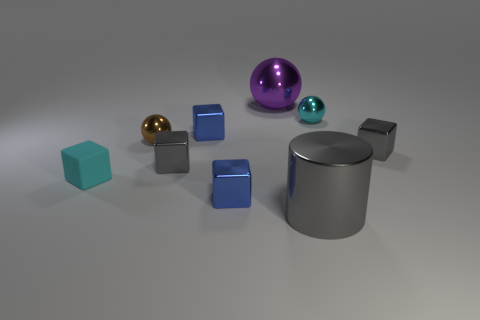What is the color of the small metallic thing that is behind the brown metallic ball and to the right of the purple metallic object?
Make the answer very short. Cyan. Is the number of big balls that are right of the purple metallic object less than the number of cyan objects behind the cyan matte block?
Your answer should be compact. Yes. What number of large gray objects are the same shape as the cyan matte object?
Give a very brief answer. 0. What size is the cyan thing that is made of the same material as the big gray object?
Offer a terse response. Small. There is a small shiny ball left of the big gray cylinder that is in front of the large purple ball; what is its color?
Give a very brief answer. Brown. Is the shape of the cyan metallic object the same as the gray thing in front of the cyan cube?
Keep it short and to the point. No. What number of blue things have the same size as the gray metal cylinder?
Make the answer very short. 0. There is a big metal thing that is in front of the big metal sphere; does it have the same color as the small shiny block to the right of the cylinder?
Offer a terse response. Yes. There is a tiny cyan object left of the cyan shiny thing; what is its shape?
Keep it short and to the point. Cube. What color is the small rubber object?
Keep it short and to the point. Cyan. 